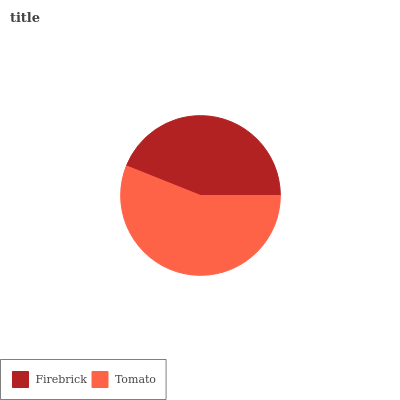Is Firebrick the minimum?
Answer yes or no. Yes. Is Tomato the maximum?
Answer yes or no. Yes. Is Tomato the minimum?
Answer yes or no. No. Is Tomato greater than Firebrick?
Answer yes or no. Yes. Is Firebrick less than Tomato?
Answer yes or no. Yes. Is Firebrick greater than Tomato?
Answer yes or no. No. Is Tomato less than Firebrick?
Answer yes or no. No. Is Tomato the high median?
Answer yes or no. Yes. Is Firebrick the low median?
Answer yes or no. Yes. Is Firebrick the high median?
Answer yes or no. No. Is Tomato the low median?
Answer yes or no. No. 